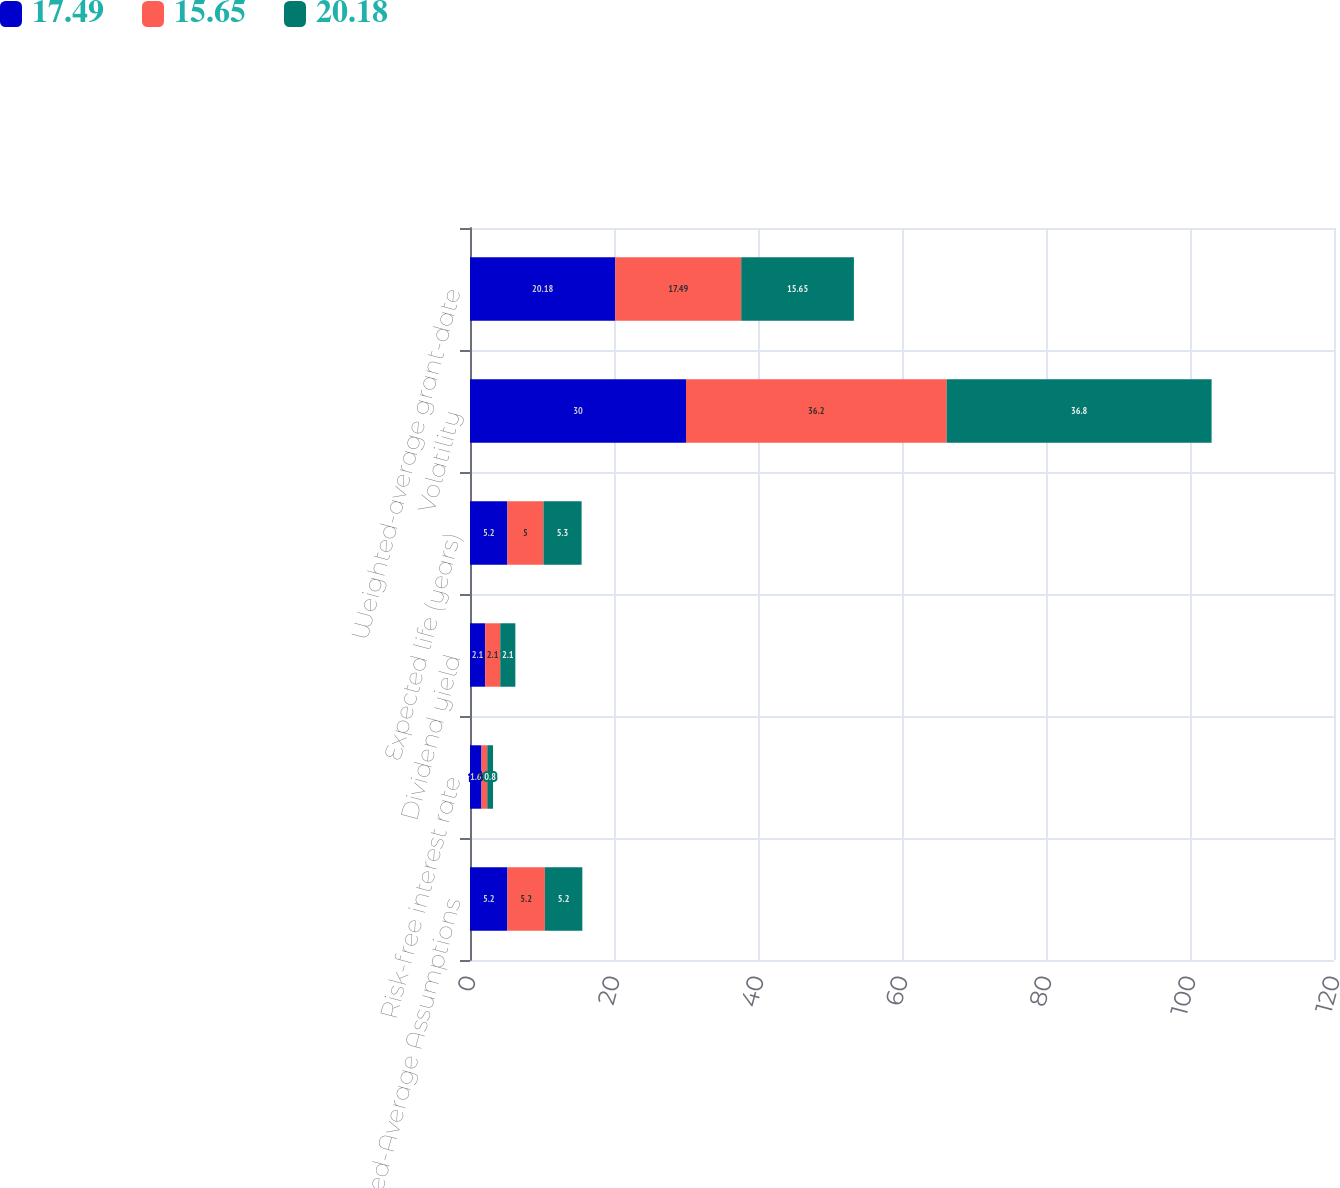Convert chart. <chart><loc_0><loc_0><loc_500><loc_500><stacked_bar_chart><ecel><fcel>Weighted-Average Assumptions<fcel>Risk-free interest rate<fcel>Dividend yield<fcel>Expected life (years)<fcel>Volatility<fcel>Weighted-average grant-date<nl><fcel>17.49<fcel>5.2<fcel>1.6<fcel>2.1<fcel>5.2<fcel>30<fcel>20.18<nl><fcel>15.65<fcel>5.2<fcel>0.8<fcel>2.1<fcel>5<fcel>36.2<fcel>17.49<nl><fcel>20.18<fcel>5.2<fcel>0.8<fcel>2.1<fcel>5.3<fcel>36.8<fcel>15.65<nl></chart> 